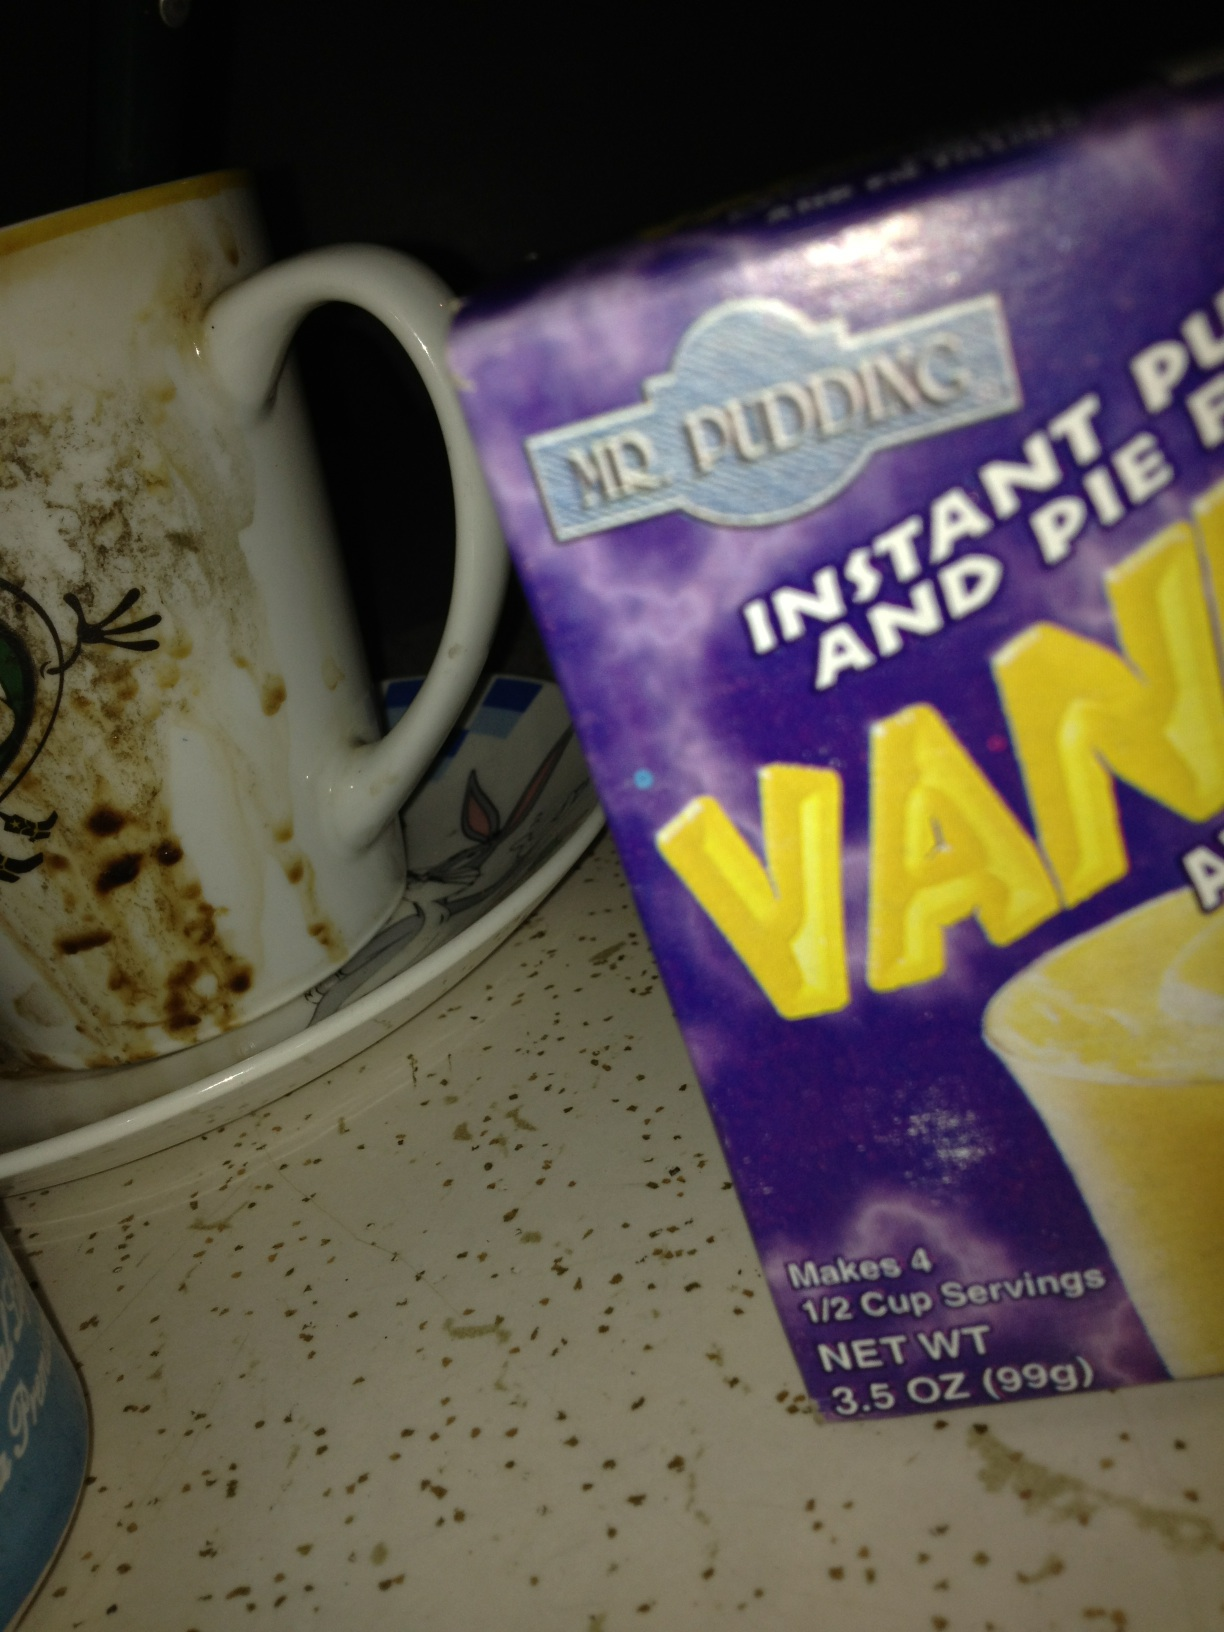What's in this box? from Vizwiz pudding mix 